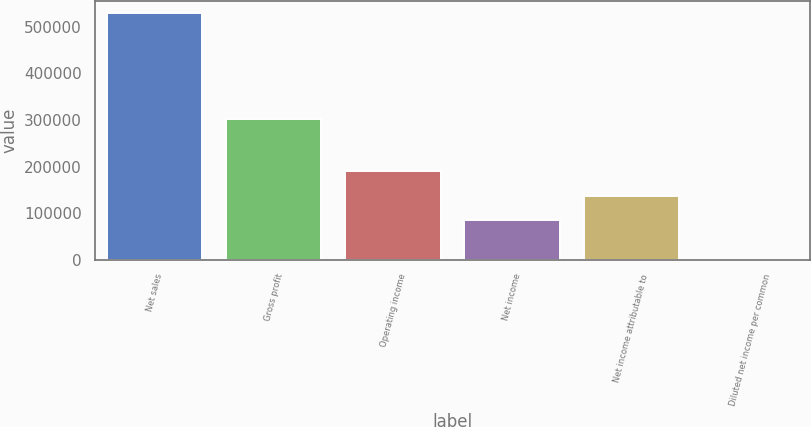Convert chart. <chart><loc_0><loc_0><loc_500><loc_500><bar_chart><fcel>Net sales<fcel>Gross profit<fcel>Operating income<fcel>Net income<fcel>Net income attributable to<fcel>Diluted net income per common<nl><fcel>528710<fcel>301959<fcel>190540<fcel>84798<fcel>137669<fcel>0.39<nl></chart> 